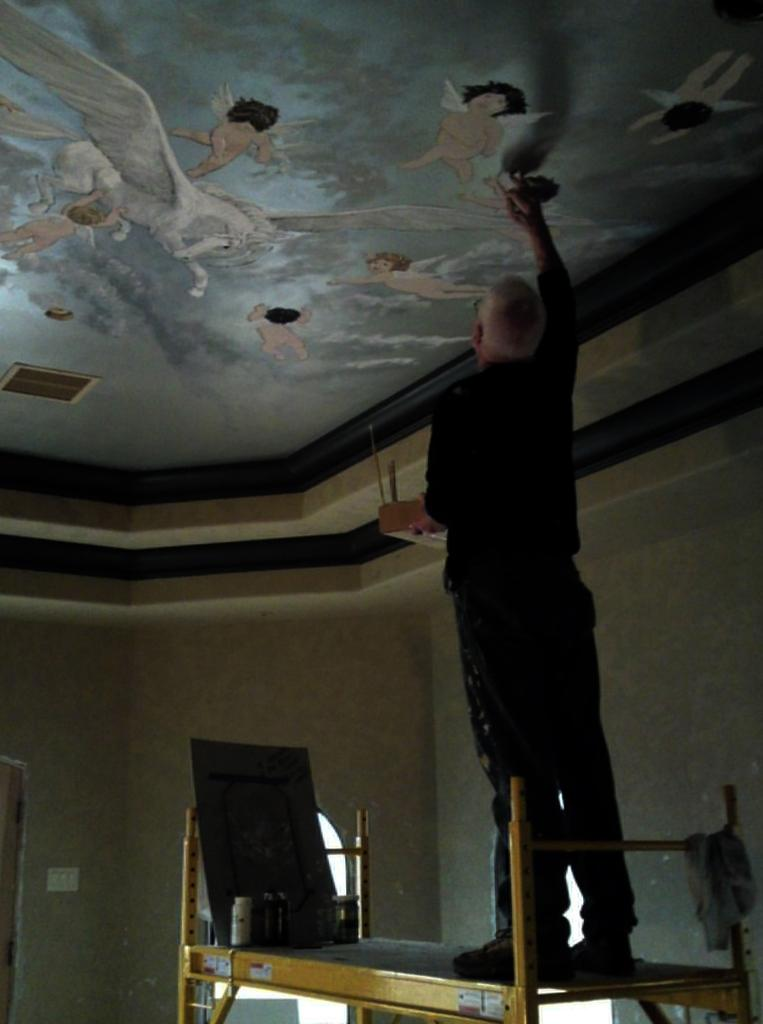What is the main subject of the image? There is a person in the image. What is the person doing in the image? The person is standing on a table and painting the roof. What else can be seen on the table besides the person? There are things on the table. What type of sail is the person using to paint the roof in the image? There is no sail present in the image; the person is standing on a table to paint the roof. 